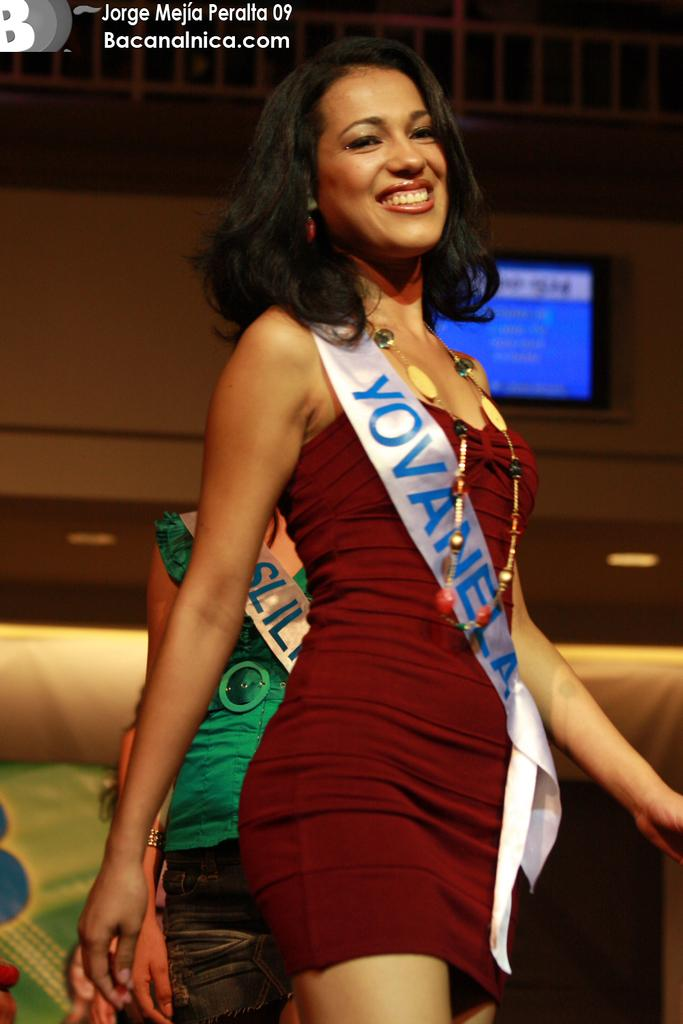<image>
Offer a succinct explanation of the picture presented. Yovanela is a pageant contestant wearing a maroon dress. 